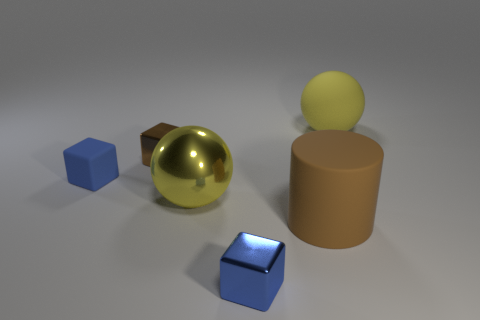How many yellow objects have the same shape as the small blue matte thing?
Your answer should be very brief. 0. There is a blue thing that is made of the same material as the tiny brown object; what is its size?
Offer a very short reply. Small. Is the number of cyan things greater than the number of cylinders?
Your answer should be very brief. No. There is a big cylinder behind the tiny blue metallic object; what color is it?
Ensure brevity in your answer.  Brown. There is a object that is on the left side of the large brown cylinder and in front of the large metallic sphere; what is its size?
Ensure brevity in your answer.  Small. What number of metal blocks are the same size as the yellow metallic sphere?
Provide a succinct answer. 0. There is another brown object that is the same shape as the small matte object; what is its material?
Keep it short and to the point. Metal. Is the large brown matte thing the same shape as the blue rubber thing?
Keep it short and to the point. No. There is a rubber block; what number of yellow things are in front of it?
Your answer should be compact. 1. There is a matte object behind the tiny blue rubber object in front of the brown cube; what shape is it?
Ensure brevity in your answer.  Sphere. 